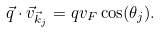Convert formula to latex. <formula><loc_0><loc_0><loc_500><loc_500>\vec { q } \cdot \vec { v } _ { \vec { k } _ { j } } = q v _ { F } \cos ( \theta _ { j } ) .</formula> 